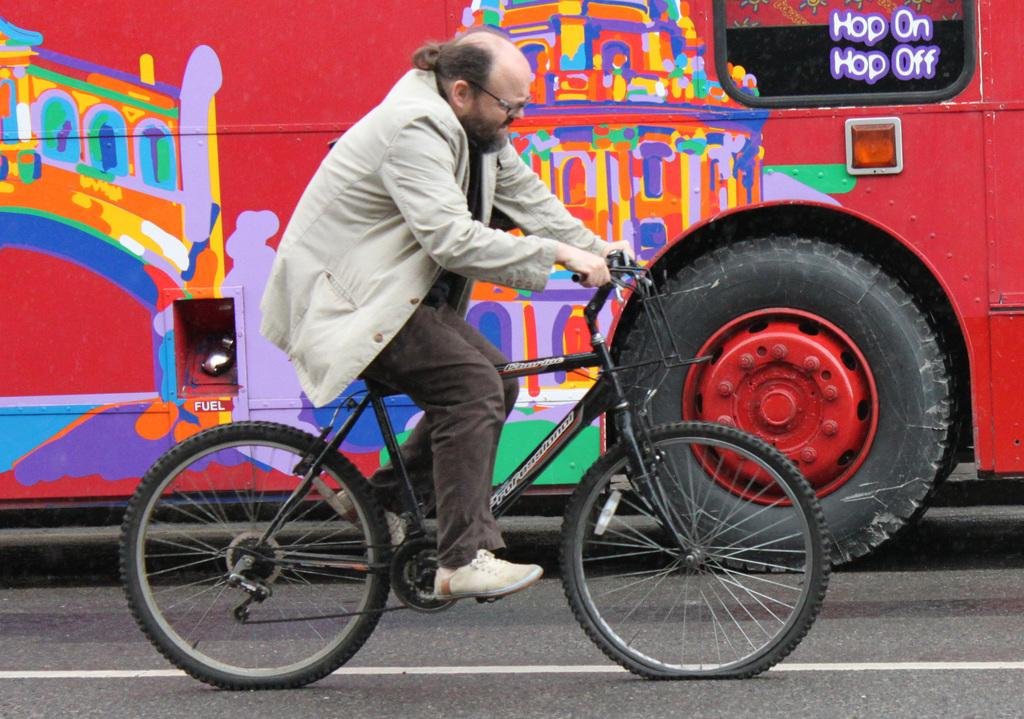What is the main mode of transportation in the image? There is a cycle in the image, and a man is riding it. Can you describe the position of the vehicle in relation to the cycle? There is a vehicle behind the cycle in the image. What type of underwear is the man wearing in the image? There is no information about the man's underwear in the image, and it cannot be determined from the provided facts. 